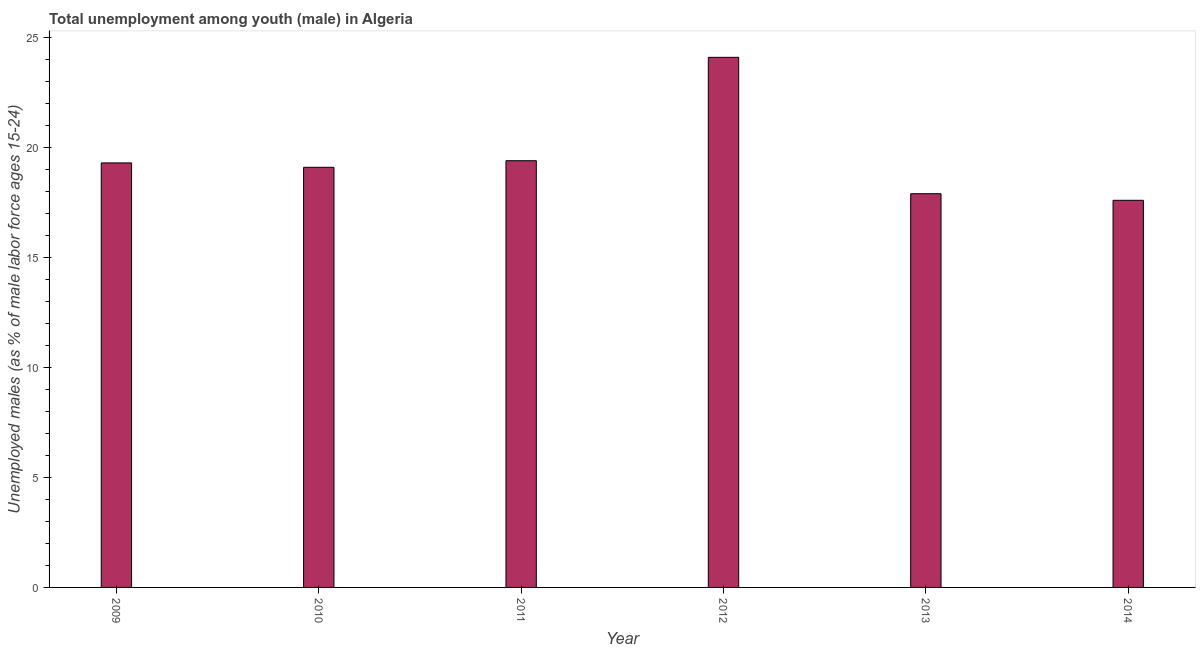Does the graph contain any zero values?
Your answer should be very brief. No. What is the title of the graph?
Your response must be concise. Total unemployment among youth (male) in Algeria. What is the label or title of the Y-axis?
Give a very brief answer. Unemployed males (as % of male labor force ages 15-24). What is the unemployed male youth population in 2012?
Provide a short and direct response. 24.1. Across all years, what is the maximum unemployed male youth population?
Keep it short and to the point. 24.1. Across all years, what is the minimum unemployed male youth population?
Ensure brevity in your answer.  17.6. In which year was the unemployed male youth population maximum?
Your answer should be very brief. 2012. In which year was the unemployed male youth population minimum?
Provide a short and direct response. 2014. What is the sum of the unemployed male youth population?
Give a very brief answer. 117.4. What is the difference between the unemployed male youth population in 2013 and 2014?
Offer a terse response. 0.3. What is the average unemployed male youth population per year?
Offer a very short reply. 19.57. What is the median unemployed male youth population?
Your response must be concise. 19.2. Do a majority of the years between 2011 and 2010 (inclusive) have unemployed male youth population greater than 13 %?
Give a very brief answer. No. What is the ratio of the unemployed male youth population in 2010 to that in 2014?
Keep it short and to the point. 1.08. Is the sum of the unemployed male youth population in 2009 and 2012 greater than the maximum unemployed male youth population across all years?
Your response must be concise. Yes. What is the difference between the highest and the lowest unemployed male youth population?
Offer a very short reply. 6.5. Are all the bars in the graph horizontal?
Your answer should be compact. No. What is the difference between two consecutive major ticks on the Y-axis?
Give a very brief answer. 5. Are the values on the major ticks of Y-axis written in scientific E-notation?
Give a very brief answer. No. What is the Unemployed males (as % of male labor force ages 15-24) in 2009?
Provide a succinct answer. 19.3. What is the Unemployed males (as % of male labor force ages 15-24) in 2010?
Your answer should be very brief. 19.1. What is the Unemployed males (as % of male labor force ages 15-24) in 2011?
Keep it short and to the point. 19.4. What is the Unemployed males (as % of male labor force ages 15-24) in 2012?
Offer a very short reply. 24.1. What is the Unemployed males (as % of male labor force ages 15-24) in 2013?
Your answer should be compact. 17.9. What is the Unemployed males (as % of male labor force ages 15-24) in 2014?
Ensure brevity in your answer.  17.6. What is the difference between the Unemployed males (as % of male labor force ages 15-24) in 2009 and 2013?
Provide a short and direct response. 1.4. What is the difference between the Unemployed males (as % of male labor force ages 15-24) in 2009 and 2014?
Offer a terse response. 1.7. What is the difference between the Unemployed males (as % of male labor force ages 15-24) in 2010 and 2011?
Your answer should be very brief. -0.3. What is the difference between the Unemployed males (as % of male labor force ages 15-24) in 2010 and 2012?
Make the answer very short. -5. What is the difference between the Unemployed males (as % of male labor force ages 15-24) in 2011 and 2012?
Offer a very short reply. -4.7. What is the difference between the Unemployed males (as % of male labor force ages 15-24) in 2011 and 2014?
Ensure brevity in your answer.  1.8. What is the difference between the Unemployed males (as % of male labor force ages 15-24) in 2012 and 2013?
Provide a succinct answer. 6.2. What is the difference between the Unemployed males (as % of male labor force ages 15-24) in 2012 and 2014?
Offer a very short reply. 6.5. What is the ratio of the Unemployed males (as % of male labor force ages 15-24) in 2009 to that in 2011?
Provide a succinct answer. 0.99. What is the ratio of the Unemployed males (as % of male labor force ages 15-24) in 2009 to that in 2012?
Make the answer very short. 0.8. What is the ratio of the Unemployed males (as % of male labor force ages 15-24) in 2009 to that in 2013?
Offer a very short reply. 1.08. What is the ratio of the Unemployed males (as % of male labor force ages 15-24) in 2009 to that in 2014?
Your answer should be compact. 1.1. What is the ratio of the Unemployed males (as % of male labor force ages 15-24) in 2010 to that in 2011?
Keep it short and to the point. 0.98. What is the ratio of the Unemployed males (as % of male labor force ages 15-24) in 2010 to that in 2012?
Provide a succinct answer. 0.79. What is the ratio of the Unemployed males (as % of male labor force ages 15-24) in 2010 to that in 2013?
Provide a short and direct response. 1.07. What is the ratio of the Unemployed males (as % of male labor force ages 15-24) in 2010 to that in 2014?
Make the answer very short. 1.08. What is the ratio of the Unemployed males (as % of male labor force ages 15-24) in 2011 to that in 2012?
Make the answer very short. 0.81. What is the ratio of the Unemployed males (as % of male labor force ages 15-24) in 2011 to that in 2013?
Give a very brief answer. 1.08. What is the ratio of the Unemployed males (as % of male labor force ages 15-24) in 2011 to that in 2014?
Make the answer very short. 1.1. What is the ratio of the Unemployed males (as % of male labor force ages 15-24) in 2012 to that in 2013?
Your answer should be compact. 1.35. What is the ratio of the Unemployed males (as % of male labor force ages 15-24) in 2012 to that in 2014?
Keep it short and to the point. 1.37. 